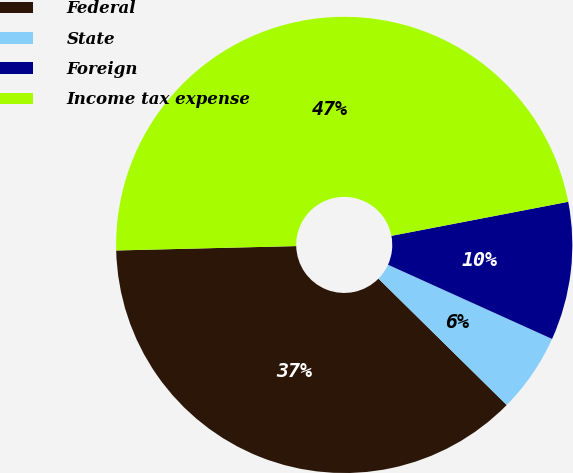<chart> <loc_0><loc_0><loc_500><loc_500><pie_chart><fcel>Federal<fcel>State<fcel>Foreign<fcel>Income tax expense<nl><fcel>37.23%<fcel>5.62%<fcel>9.79%<fcel>47.36%<nl></chart> 